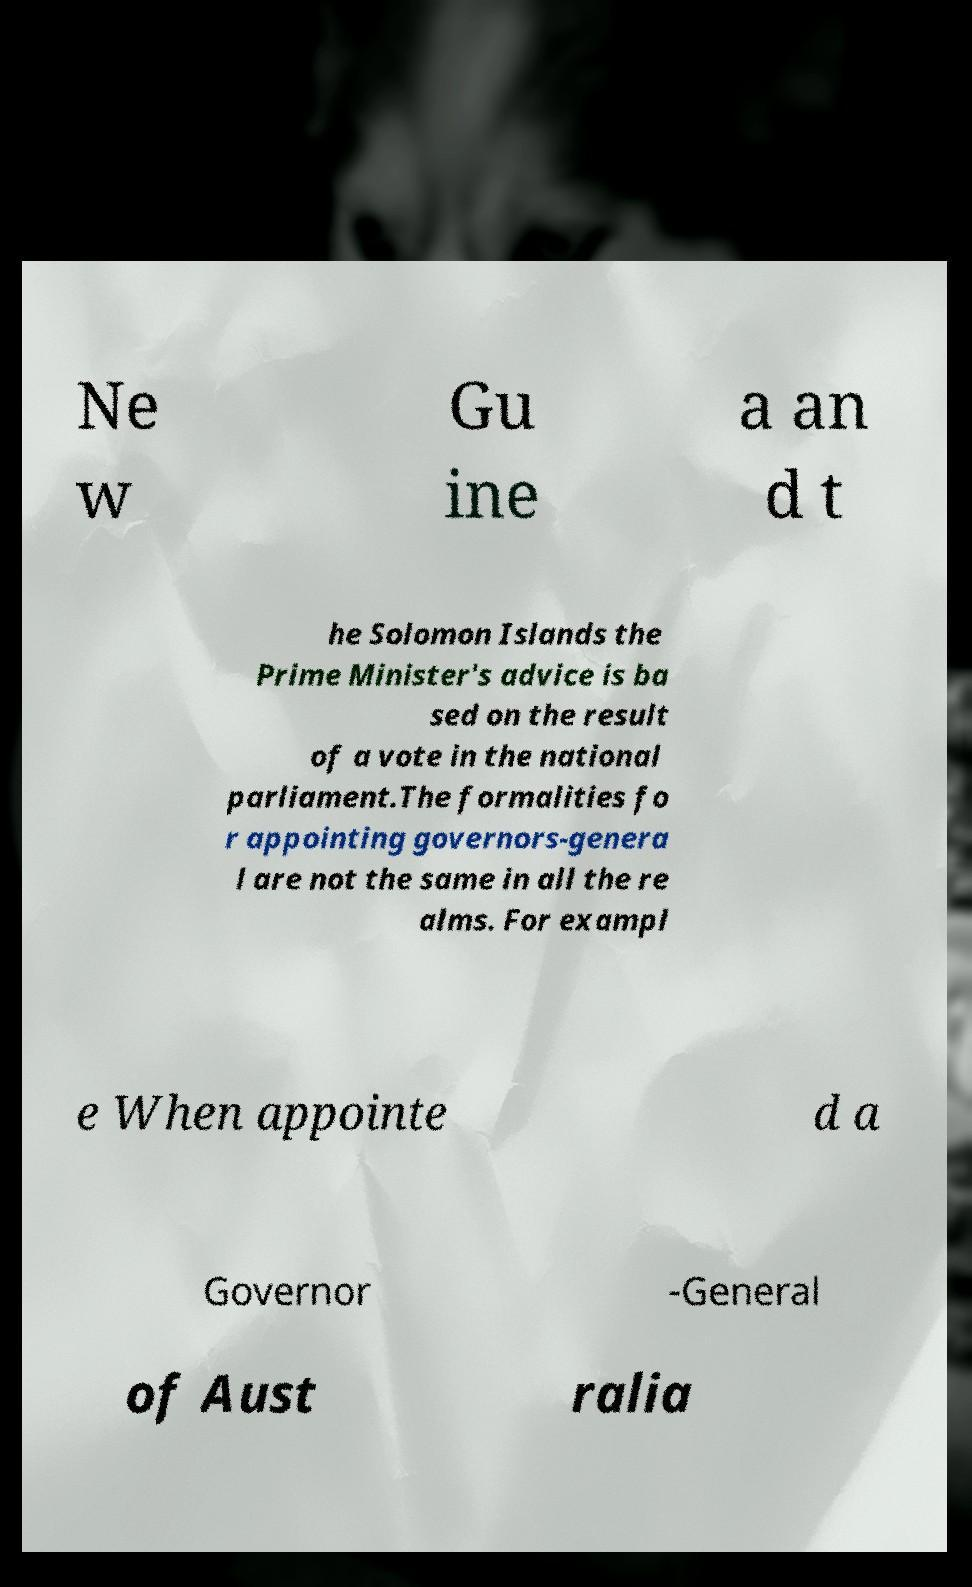Can you accurately transcribe the text from the provided image for me? Ne w Gu ine a an d t he Solomon Islands the Prime Minister's advice is ba sed on the result of a vote in the national parliament.The formalities fo r appointing governors-genera l are not the same in all the re alms. For exampl e When appointe d a Governor -General of Aust ralia 